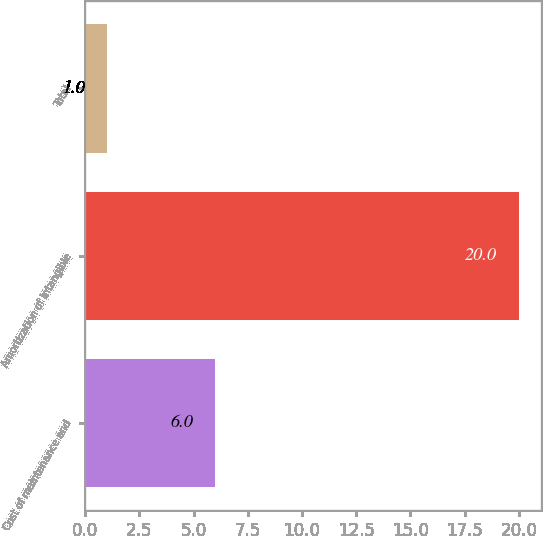Convert chart. <chart><loc_0><loc_0><loc_500><loc_500><bar_chart><fcel>Cost of maintenance and<fcel>Amortization of intangible<fcel>Total<nl><fcel>6<fcel>20<fcel>1<nl></chart> 